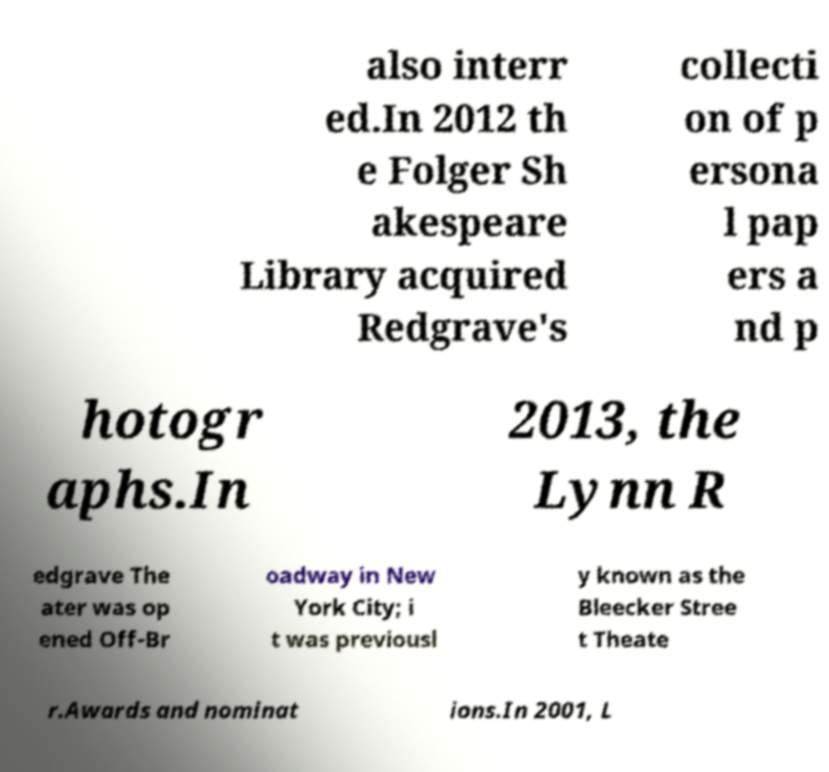Can you accurately transcribe the text from the provided image for me? also interr ed.In 2012 th e Folger Sh akespeare Library acquired Redgrave's collecti on of p ersona l pap ers a nd p hotogr aphs.In 2013, the Lynn R edgrave The ater was op ened Off-Br oadway in New York City; i t was previousl y known as the Bleecker Stree t Theate r.Awards and nominat ions.In 2001, L 